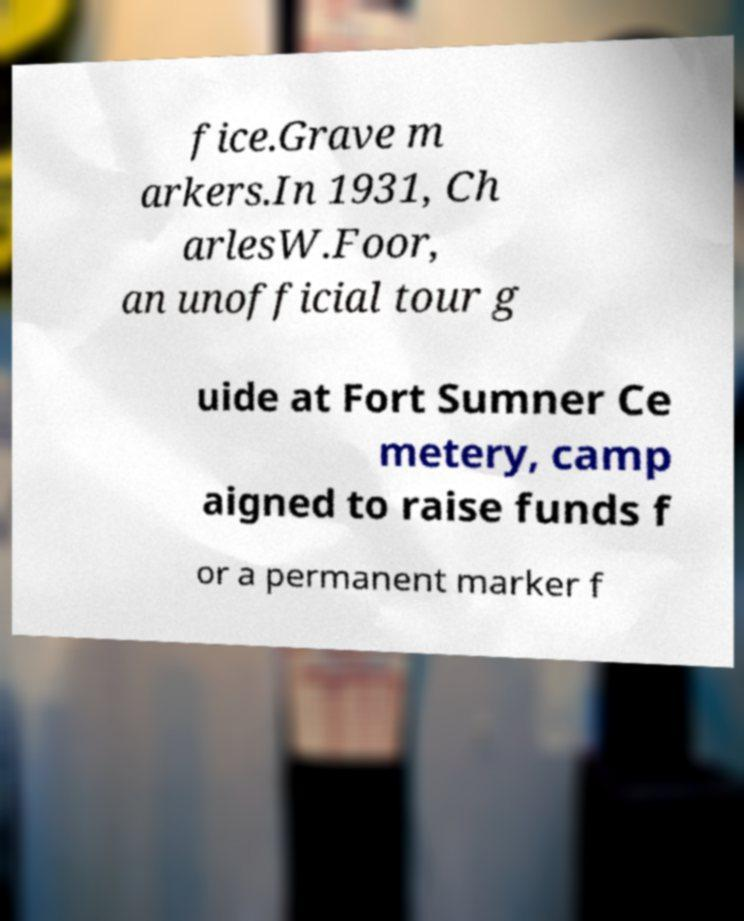Could you extract and type out the text from this image? fice.Grave m arkers.In 1931, Ch arlesW.Foor, an unofficial tour g uide at Fort Sumner Ce metery, camp aigned to raise funds f or a permanent marker f 